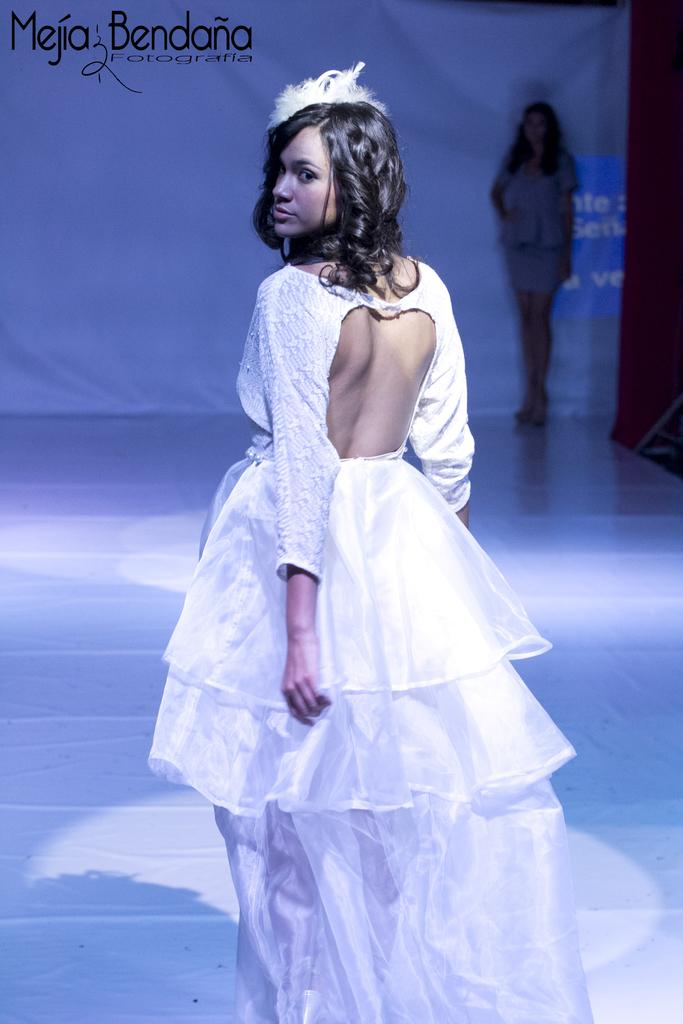How many people are present in the image? There are two persons standing in the image. What can be seen in the background of the image? There is a banner in the background of the image. Is there any additional information or marking on the image? Yes, there is a watermark on the image. What type of oatmeal is being served on the table in the image? There is no table or oatmeal present in the image; it only features two persons and a banner in the background. 